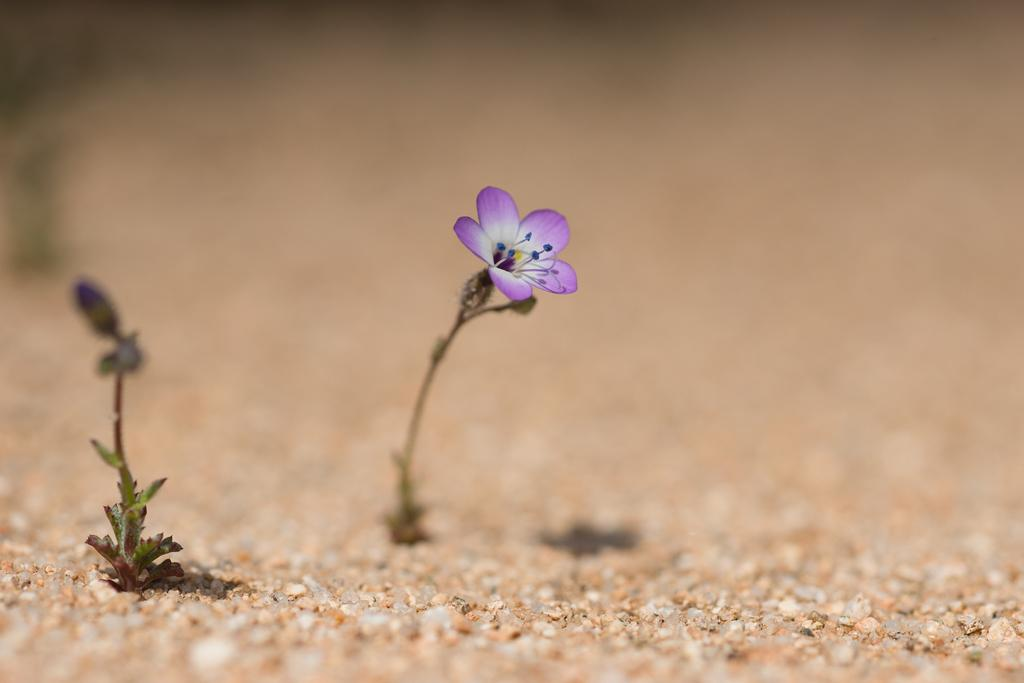What type of flower is present in the image? There is a violet color flower with five petals in the image. What can be seen at the bottom of the image? Small stones are visible at the bottom of the image. How would you describe the background of the image? The background of the image is blurred. Where is the rake being used in the image? There is no rake present in the image. What type of yak can be seen grazing in the background of the image? There is no yak present in the image; the background is blurred. 